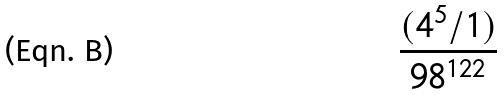<formula> <loc_0><loc_0><loc_500><loc_500>\frac { ( 4 ^ { 5 } / 1 ) } { 9 8 ^ { 1 2 2 } }</formula> 